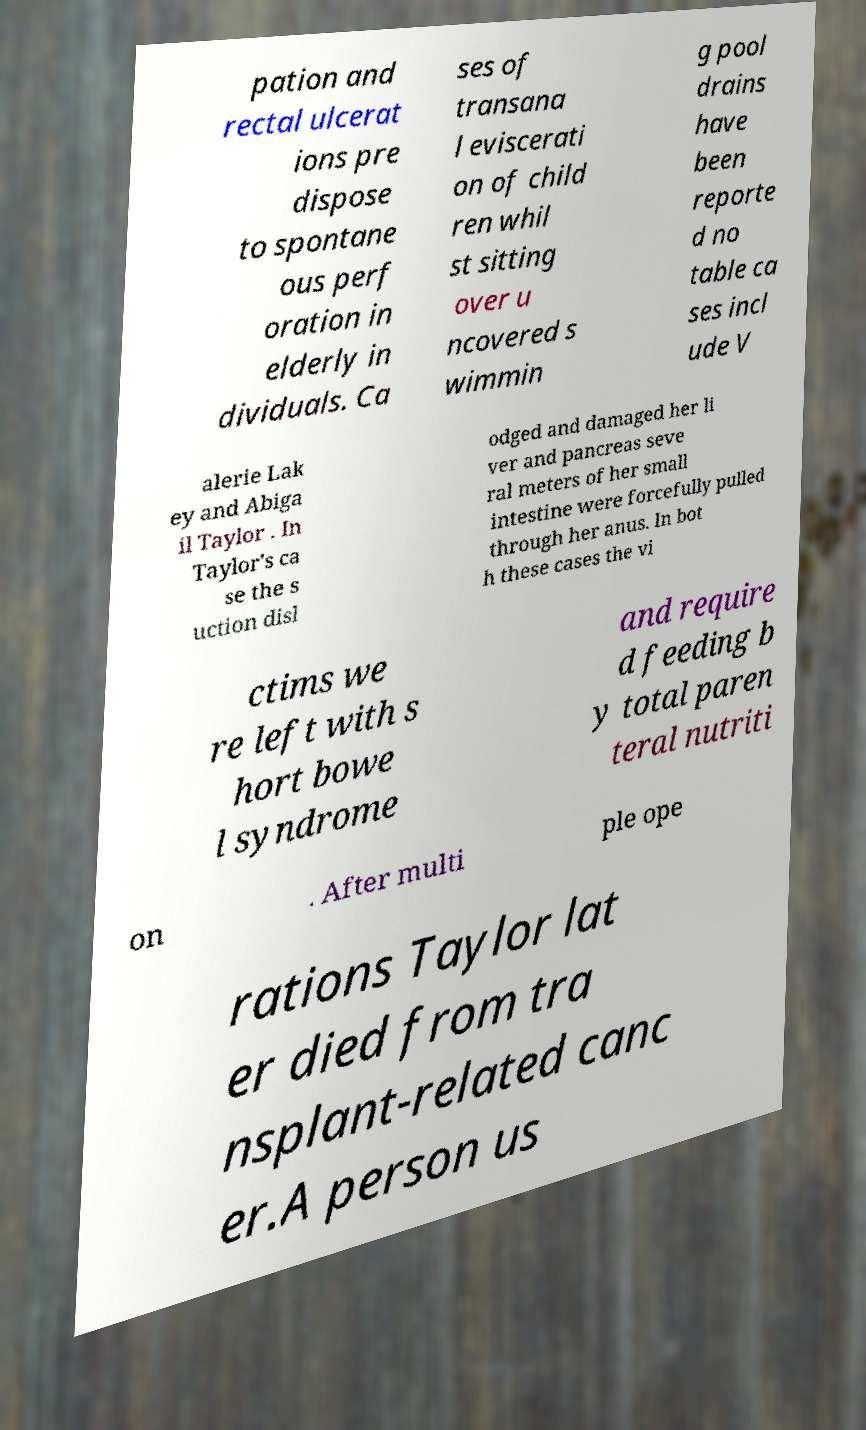What messages or text are displayed in this image? I need them in a readable, typed format. pation and rectal ulcerat ions pre dispose to spontane ous perf oration in elderly in dividuals. Ca ses of transana l eviscerati on of child ren whil st sitting over u ncovered s wimmin g pool drains have been reporte d no table ca ses incl ude V alerie Lak ey and Abiga il Taylor . In Taylor's ca se the s uction disl odged and damaged her li ver and pancreas seve ral meters of her small intestine were forcefully pulled through her anus. In bot h these cases the vi ctims we re left with s hort bowe l syndrome and require d feeding b y total paren teral nutriti on . After multi ple ope rations Taylor lat er died from tra nsplant-related canc er.A person us 